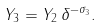<formula> <loc_0><loc_0><loc_500><loc_500>Y _ { 3 } = Y _ { 2 } \, \delta ^ { - \sigma _ { 3 } } .</formula> 